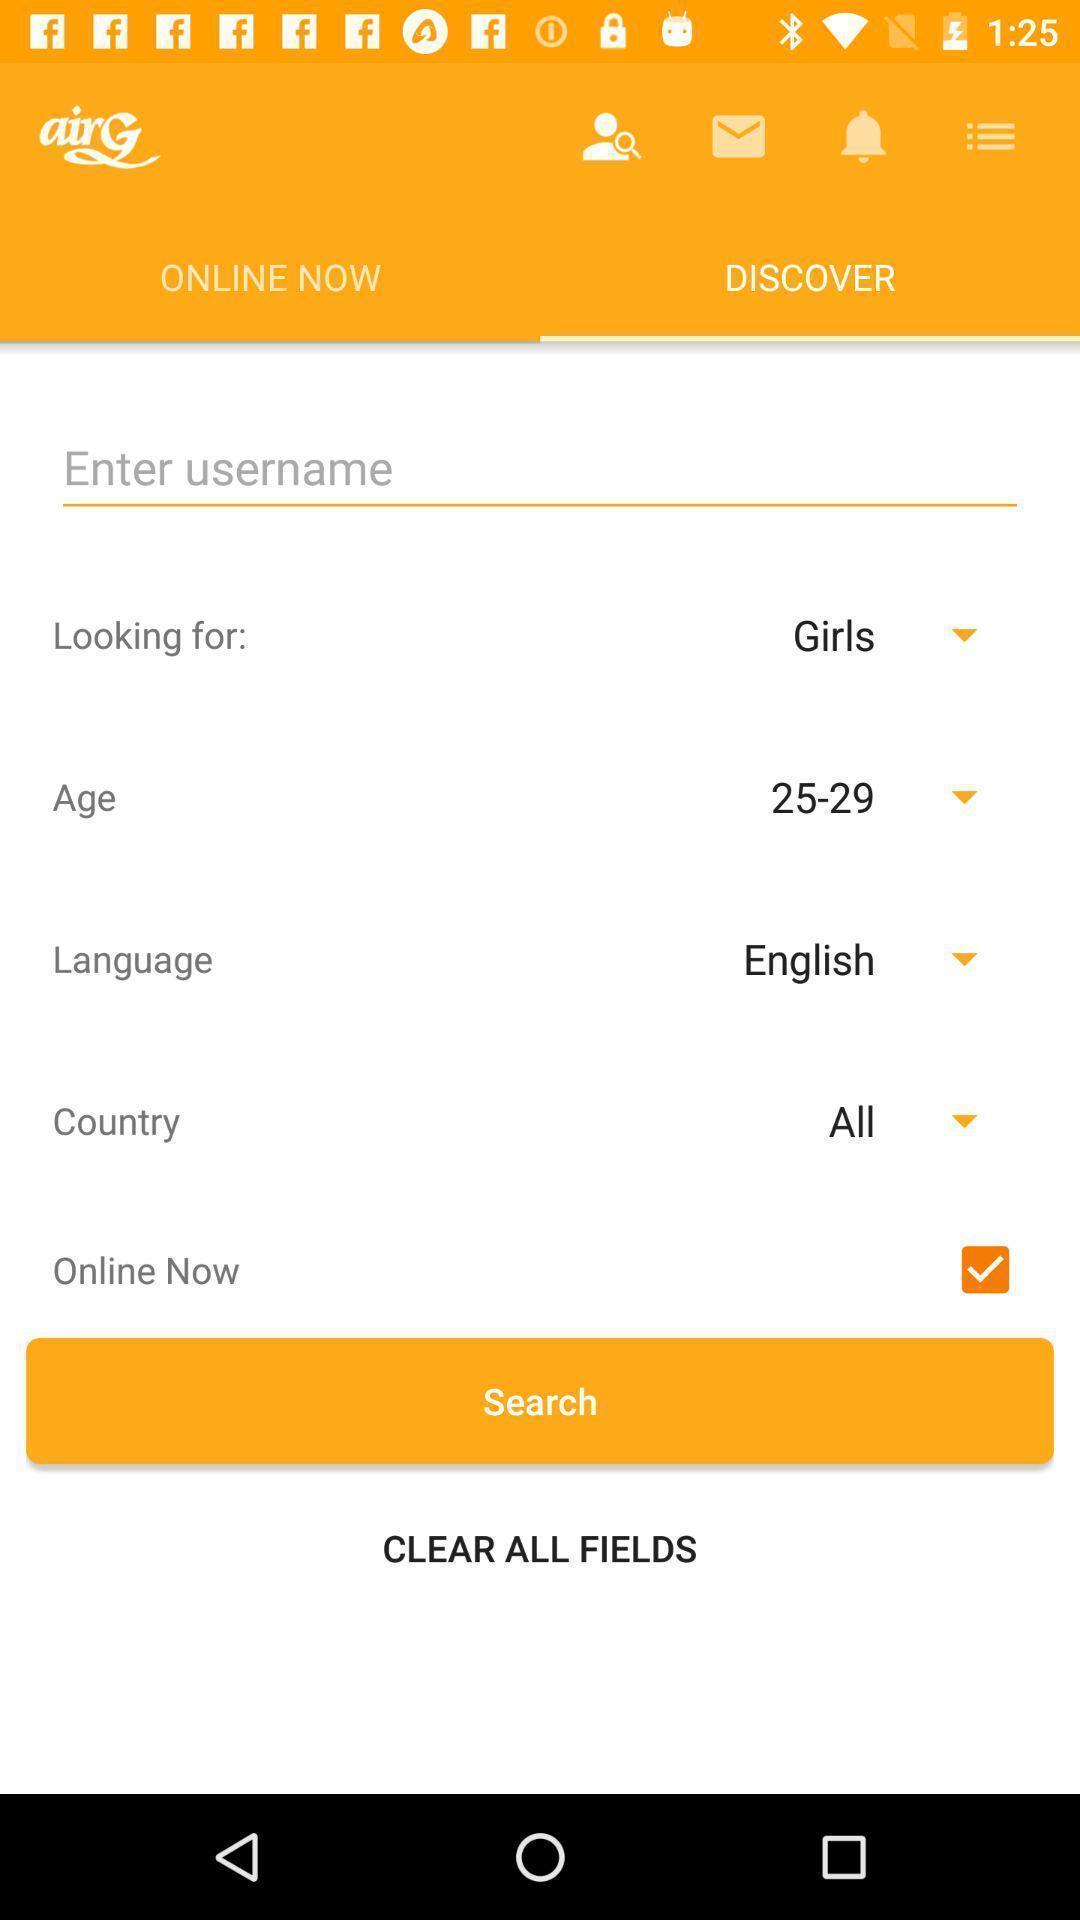Provide a textual representation of this image. Search bar to search for the username. 